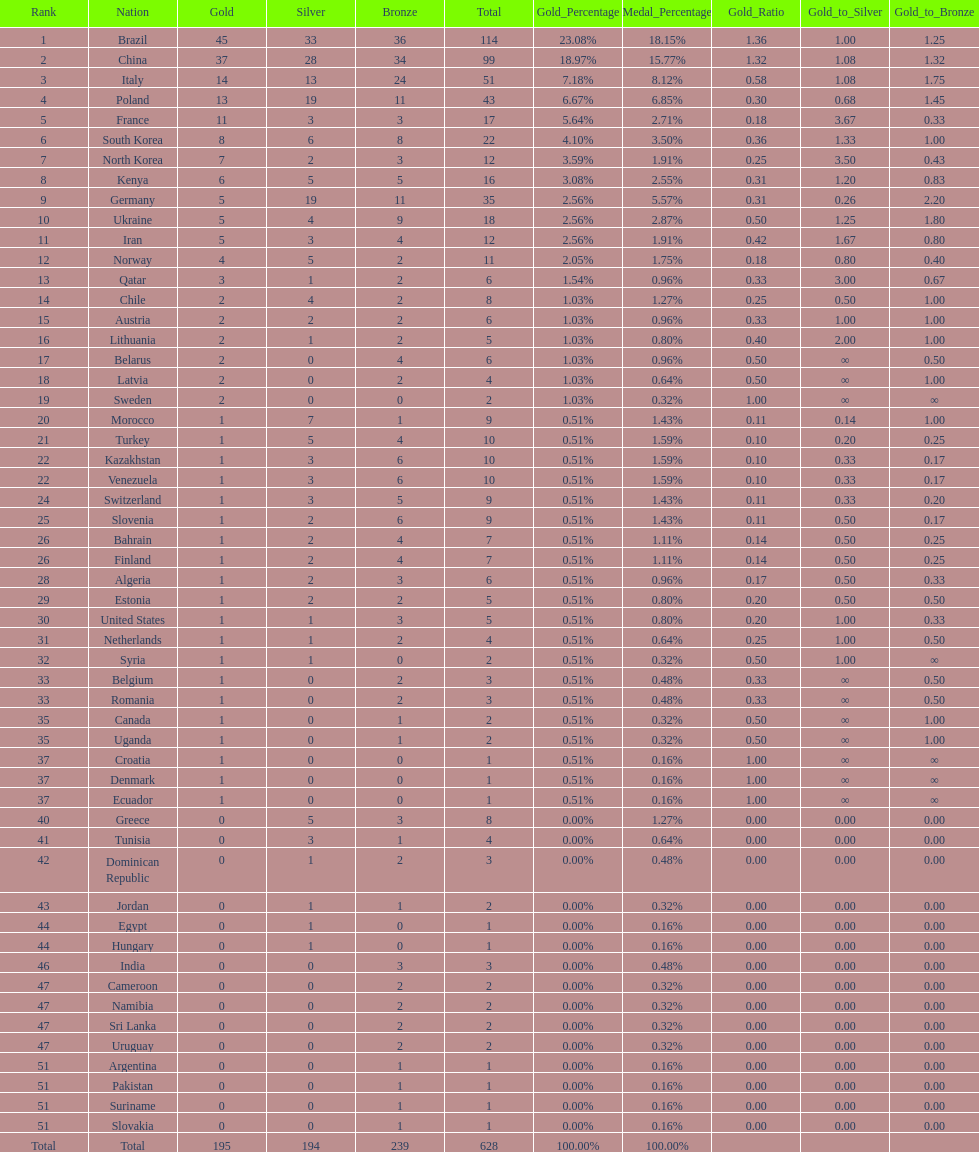Who won more gold medals, brazil or china? Brazil. 